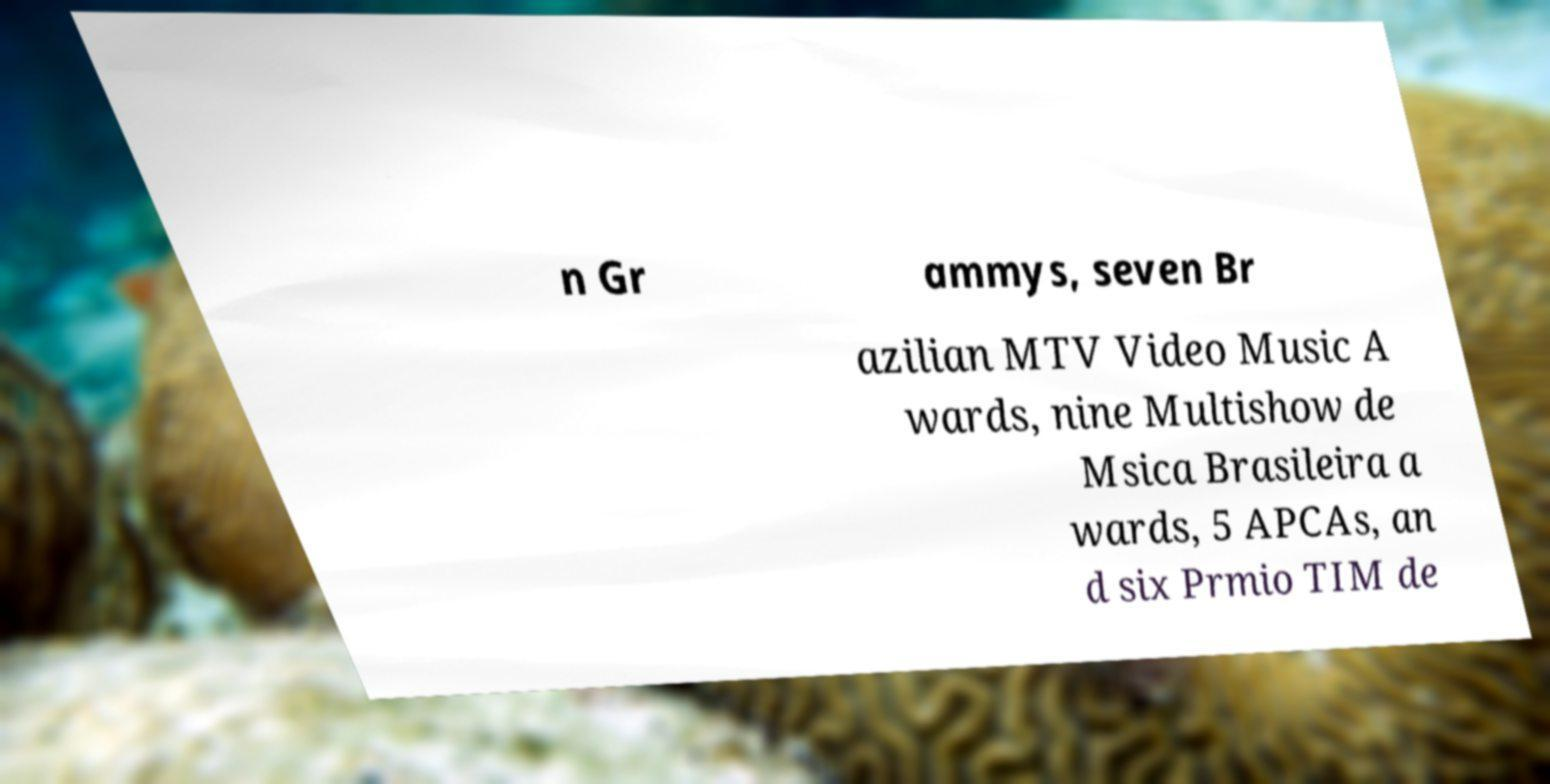Can you read and provide the text displayed in the image?This photo seems to have some interesting text. Can you extract and type it out for me? n Gr ammys, seven Br azilian MTV Video Music A wards, nine Multishow de Msica Brasileira a wards, 5 APCAs, an d six Prmio TIM de 